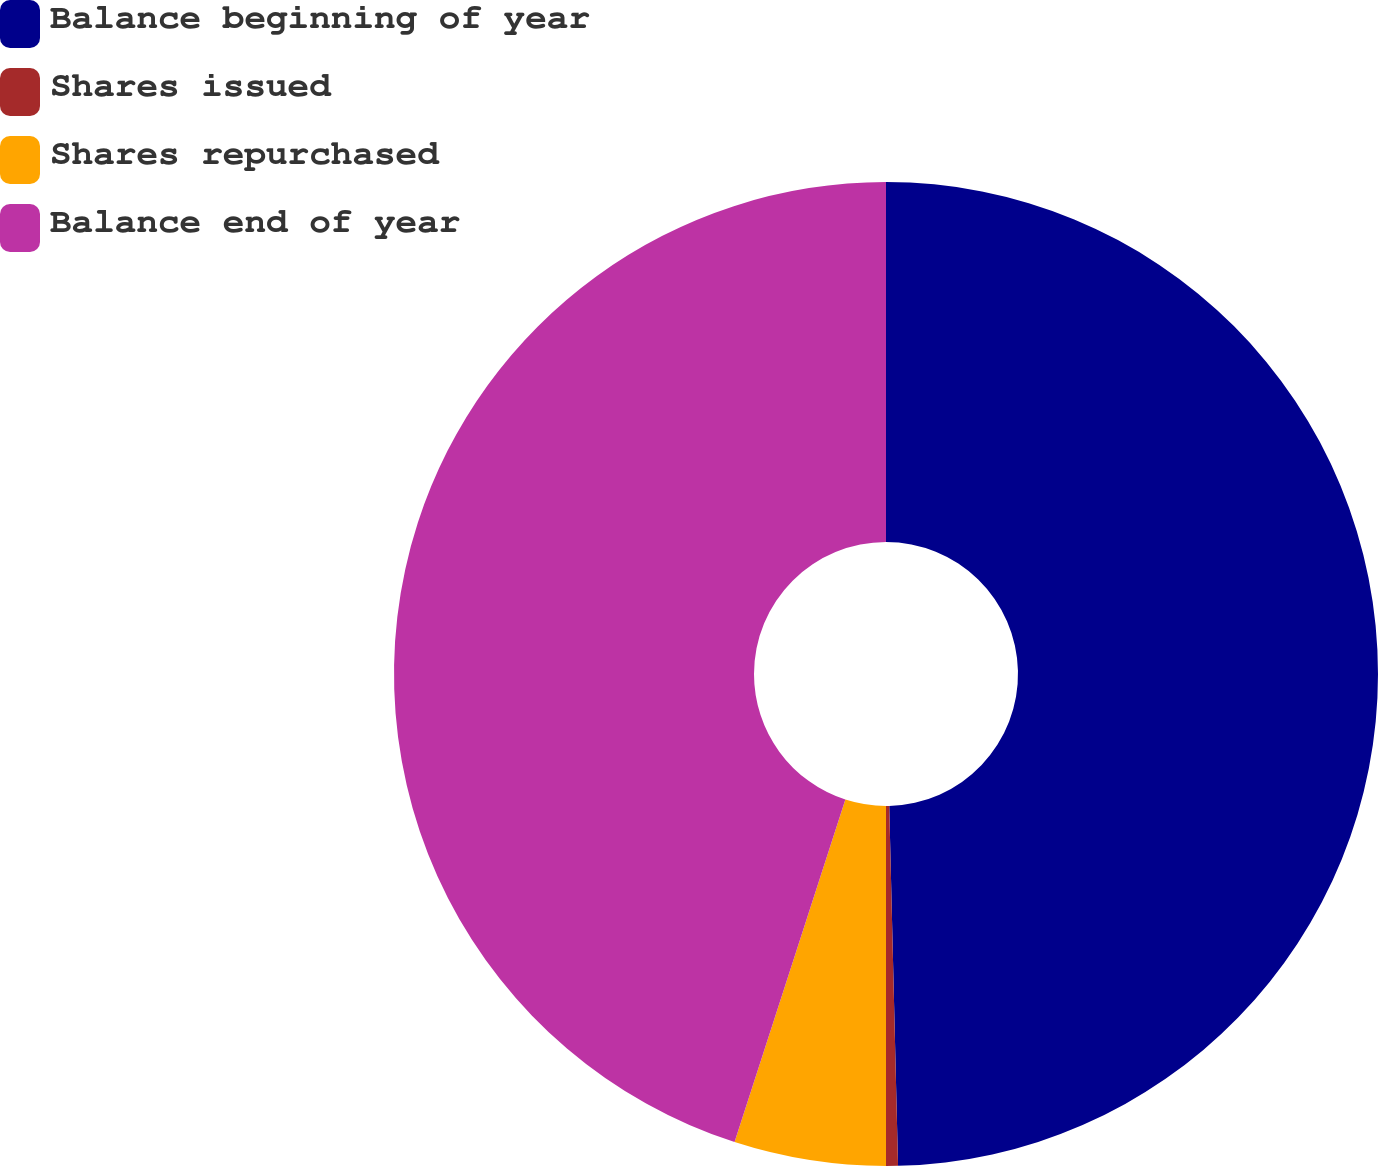Convert chart to OTSL. <chart><loc_0><loc_0><loc_500><loc_500><pie_chart><fcel>Balance beginning of year<fcel>Shares issued<fcel>Shares repurchased<fcel>Balance end of year<nl><fcel>49.61%<fcel>0.39%<fcel>4.98%<fcel>45.02%<nl></chart> 